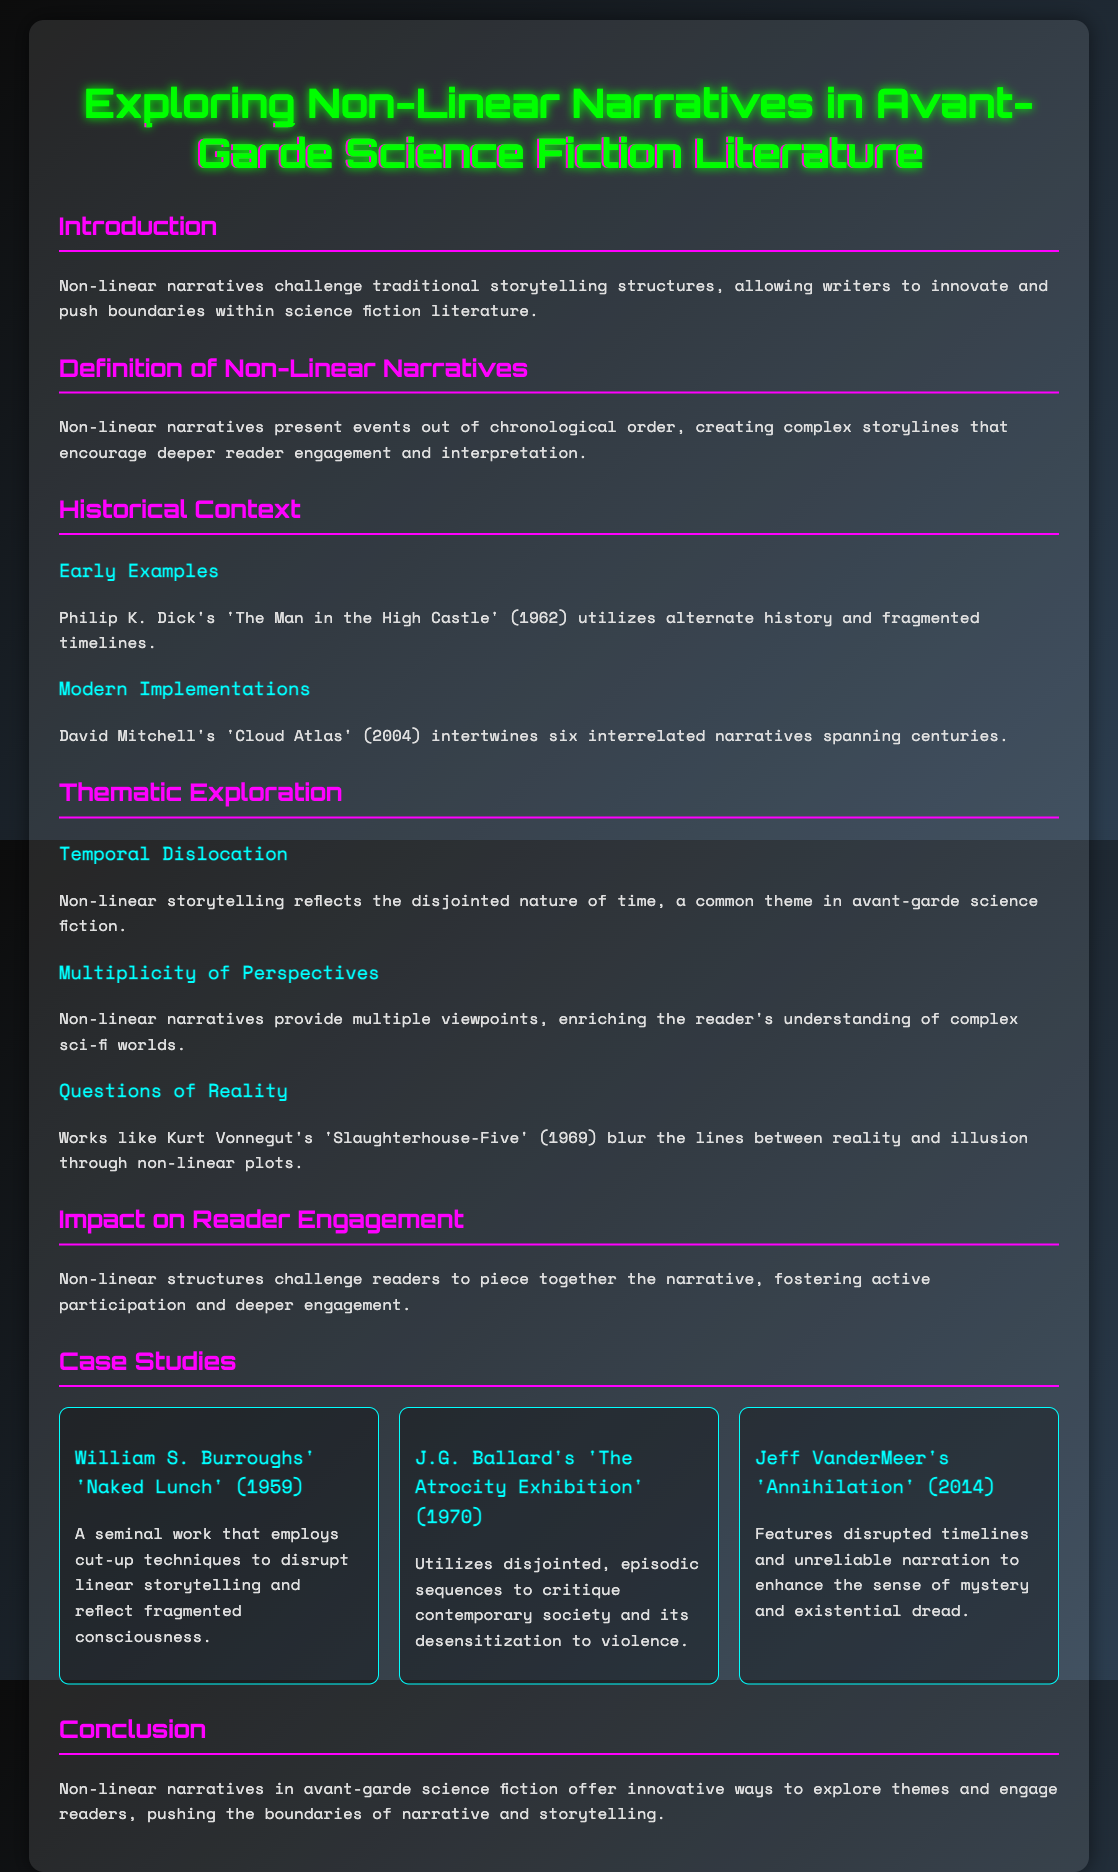What is the title of the presentation? The title is prominently displayed at the top of the document, labeled clearly.
Answer: Exploring Non-Linear Narratives in Avant-Garde Science Fiction Literature Who is an early example of non-linear narrative mentioned in the document? The document includes early examples of non-linear narratives in science fiction literature, identifying a key author.
Answer: Philip K. Dick What year was 'Cloud Atlas' published? The publication date is mentioned in the context of modern implementations of non-linear storytelling.
Answer: 2004 What theme does non-linear storytelling reflect according to the document? The document discusses how non-linear storytelling represents a certain thematic exploration.
Answer: Temporal Dislocation Which work by Kurt Vonnegut is referenced in the thematic exploration? The document lists specific works associated with themes in non-linear narratives, including this famous book by Vonnegut.
Answer: Slaughterhouse-Five How many case studies are presented in the document? The document outlines a section dedicated to case studies, providing a specific count of those featured works.
Answer: Three What technique does 'Naked Lunch' employ according to the case study? This document describes the technique used in 'Naked Lunch' as part of its non-linear narrative structure.
Answer: Cut-up techniques What is the focus of the conclusion in the document? The conclusion summarizes the main argument or insight conveyed in the presentation regarding non-linear narratives.
Answer: Innovative ways to explore themes and engage readers 